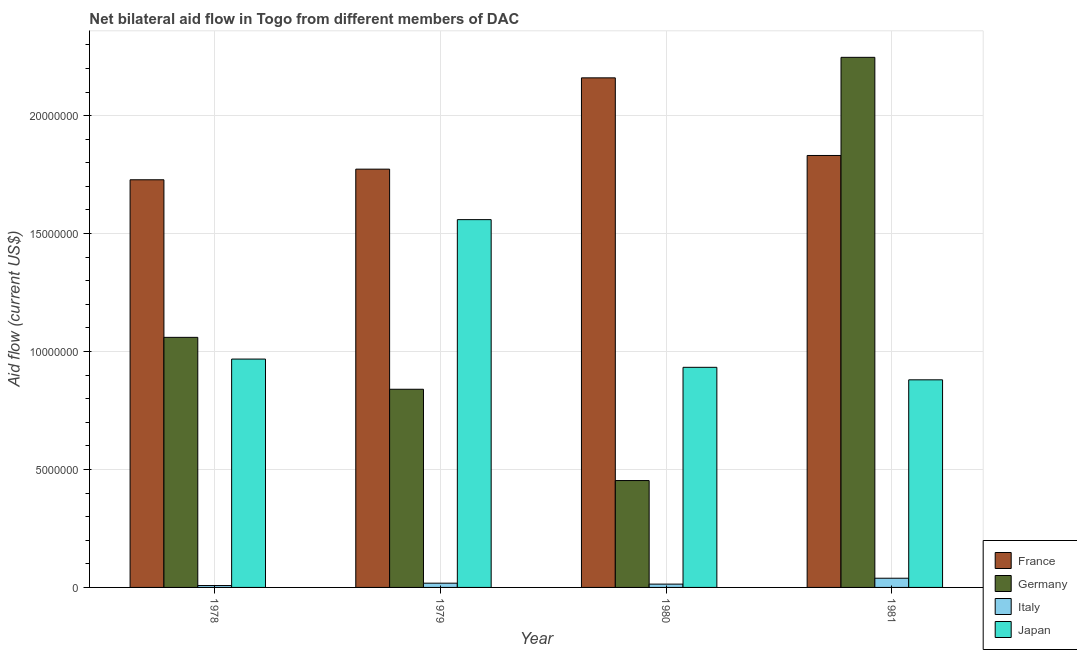How many different coloured bars are there?
Offer a terse response. 4. Are the number of bars per tick equal to the number of legend labels?
Make the answer very short. Yes. How many bars are there on the 3rd tick from the right?
Offer a terse response. 4. What is the label of the 3rd group of bars from the left?
Provide a short and direct response. 1980. What is the amount of aid given by italy in 1980?
Provide a short and direct response. 1.40e+05. Across all years, what is the maximum amount of aid given by france?
Offer a terse response. 2.16e+07. Across all years, what is the minimum amount of aid given by italy?
Keep it short and to the point. 8.00e+04. In which year was the amount of aid given by italy minimum?
Offer a terse response. 1978. What is the total amount of aid given by germany in the graph?
Give a very brief answer. 4.60e+07. What is the difference between the amount of aid given by italy in 1979 and that in 1980?
Your answer should be very brief. 4.00e+04. What is the difference between the amount of aid given by italy in 1979 and the amount of aid given by germany in 1980?
Your answer should be very brief. 4.00e+04. What is the average amount of aid given by france per year?
Provide a succinct answer. 1.87e+07. In how many years, is the amount of aid given by germany greater than 20000000 US$?
Your answer should be very brief. 1. What is the ratio of the amount of aid given by japan in 1978 to that in 1979?
Make the answer very short. 0.62. Is the amount of aid given by france in 1979 less than that in 1980?
Your answer should be compact. Yes. What is the difference between the highest and the second highest amount of aid given by italy?
Make the answer very short. 2.10e+05. What is the difference between the highest and the lowest amount of aid given by italy?
Provide a succinct answer. 3.10e+05. Is the sum of the amount of aid given by germany in 1978 and 1981 greater than the maximum amount of aid given by italy across all years?
Offer a very short reply. Yes. How many bars are there?
Offer a terse response. 16. Are all the bars in the graph horizontal?
Make the answer very short. No. What is the difference between two consecutive major ticks on the Y-axis?
Your answer should be compact. 5.00e+06. Are the values on the major ticks of Y-axis written in scientific E-notation?
Provide a succinct answer. No. Does the graph contain any zero values?
Your response must be concise. No. Does the graph contain grids?
Offer a very short reply. Yes. How many legend labels are there?
Keep it short and to the point. 4. What is the title of the graph?
Your response must be concise. Net bilateral aid flow in Togo from different members of DAC. Does "Austria" appear as one of the legend labels in the graph?
Ensure brevity in your answer.  No. What is the Aid flow (current US$) in France in 1978?
Offer a terse response. 1.73e+07. What is the Aid flow (current US$) in Germany in 1978?
Make the answer very short. 1.06e+07. What is the Aid flow (current US$) of Japan in 1978?
Offer a terse response. 9.68e+06. What is the Aid flow (current US$) of France in 1979?
Keep it short and to the point. 1.77e+07. What is the Aid flow (current US$) of Germany in 1979?
Make the answer very short. 8.40e+06. What is the Aid flow (current US$) in Japan in 1979?
Your answer should be compact. 1.56e+07. What is the Aid flow (current US$) in France in 1980?
Your answer should be very brief. 2.16e+07. What is the Aid flow (current US$) in Germany in 1980?
Provide a succinct answer. 4.53e+06. What is the Aid flow (current US$) in Japan in 1980?
Make the answer very short. 9.33e+06. What is the Aid flow (current US$) in France in 1981?
Ensure brevity in your answer.  1.83e+07. What is the Aid flow (current US$) in Germany in 1981?
Your response must be concise. 2.25e+07. What is the Aid flow (current US$) of Japan in 1981?
Provide a succinct answer. 8.80e+06. Across all years, what is the maximum Aid flow (current US$) of France?
Ensure brevity in your answer.  2.16e+07. Across all years, what is the maximum Aid flow (current US$) of Germany?
Your response must be concise. 2.25e+07. Across all years, what is the maximum Aid flow (current US$) in Japan?
Your response must be concise. 1.56e+07. Across all years, what is the minimum Aid flow (current US$) of France?
Your answer should be compact. 1.73e+07. Across all years, what is the minimum Aid flow (current US$) of Germany?
Keep it short and to the point. 4.53e+06. Across all years, what is the minimum Aid flow (current US$) of Italy?
Your answer should be very brief. 8.00e+04. Across all years, what is the minimum Aid flow (current US$) of Japan?
Give a very brief answer. 8.80e+06. What is the total Aid flow (current US$) in France in the graph?
Provide a succinct answer. 7.49e+07. What is the total Aid flow (current US$) in Germany in the graph?
Your response must be concise. 4.60e+07. What is the total Aid flow (current US$) in Italy in the graph?
Ensure brevity in your answer.  7.90e+05. What is the total Aid flow (current US$) of Japan in the graph?
Provide a short and direct response. 4.34e+07. What is the difference between the Aid flow (current US$) in France in 1978 and that in 1979?
Offer a very short reply. -4.50e+05. What is the difference between the Aid flow (current US$) of Germany in 1978 and that in 1979?
Provide a short and direct response. 2.20e+06. What is the difference between the Aid flow (current US$) in Japan in 1978 and that in 1979?
Provide a short and direct response. -5.91e+06. What is the difference between the Aid flow (current US$) in France in 1978 and that in 1980?
Make the answer very short. -4.32e+06. What is the difference between the Aid flow (current US$) in Germany in 1978 and that in 1980?
Make the answer very short. 6.07e+06. What is the difference between the Aid flow (current US$) of Italy in 1978 and that in 1980?
Offer a very short reply. -6.00e+04. What is the difference between the Aid flow (current US$) in France in 1978 and that in 1981?
Make the answer very short. -1.03e+06. What is the difference between the Aid flow (current US$) of Germany in 1978 and that in 1981?
Offer a terse response. -1.19e+07. What is the difference between the Aid flow (current US$) in Italy in 1978 and that in 1981?
Provide a short and direct response. -3.10e+05. What is the difference between the Aid flow (current US$) in Japan in 1978 and that in 1981?
Offer a very short reply. 8.80e+05. What is the difference between the Aid flow (current US$) in France in 1979 and that in 1980?
Your response must be concise. -3.87e+06. What is the difference between the Aid flow (current US$) in Germany in 1979 and that in 1980?
Keep it short and to the point. 3.87e+06. What is the difference between the Aid flow (current US$) of Japan in 1979 and that in 1980?
Offer a very short reply. 6.26e+06. What is the difference between the Aid flow (current US$) of France in 1979 and that in 1981?
Offer a terse response. -5.80e+05. What is the difference between the Aid flow (current US$) of Germany in 1979 and that in 1981?
Give a very brief answer. -1.41e+07. What is the difference between the Aid flow (current US$) of Italy in 1979 and that in 1981?
Your answer should be compact. -2.10e+05. What is the difference between the Aid flow (current US$) of Japan in 1979 and that in 1981?
Offer a very short reply. 6.79e+06. What is the difference between the Aid flow (current US$) of France in 1980 and that in 1981?
Make the answer very short. 3.29e+06. What is the difference between the Aid flow (current US$) of Germany in 1980 and that in 1981?
Provide a succinct answer. -1.79e+07. What is the difference between the Aid flow (current US$) of Italy in 1980 and that in 1981?
Give a very brief answer. -2.50e+05. What is the difference between the Aid flow (current US$) in Japan in 1980 and that in 1981?
Offer a very short reply. 5.30e+05. What is the difference between the Aid flow (current US$) of France in 1978 and the Aid flow (current US$) of Germany in 1979?
Ensure brevity in your answer.  8.88e+06. What is the difference between the Aid flow (current US$) of France in 1978 and the Aid flow (current US$) of Italy in 1979?
Keep it short and to the point. 1.71e+07. What is the difference between the Aid flow (current US$) in France in 1978 and the Aid flow (current US$) in Japan in 1979?
Your answer should be very brief. 1.69e+06. What is the difference between the Aid flow (current US$) of Germany in 1978 and the Aid flow (current US$) of Italy in 1979?
Offer a very short reply. 1.04e+07. What is the difference between the Aid flow (current US$) of Germany in 1978 and the Aid flow (current US$) of Japan in 1979?
Your answer should be compact. -4.99e+06. What is the difference between the Aid flow (current US$) in Italy in 1978 and the Aid flow (current US$) in Japan in 1979?
Keep it short and to the point. -1.55e+07. What is the difference between the Aid flow (current US$) of France in 1978 and the Aid flow (current US$) of Germany in 1980?
Your response must be concise. 1.28e+07. What is the difference between the Aid flow (current US$) of France in 1978 and the Aid flow (current US$) of Italy in 1980?
Offer a terse response. 1.71e+07. What is the difference between the Aid flow (current US$) of France in 1978 and the Aid flow (current US$) of Japan in 1980?
Offer a very short reply. 7.95e+06. What is the difference between the Aid flow (current US$) in Germany in 1978 and the Aid flow (current US$) in Italy in 1980?
Your answer should be compact. 1.05e+07. What is the difference between the Aid flow (current US$) of Germany in 1978 and the Aid flow (current US$) of Japan in 1980?
Give a very brief answer. 1.27e+06. What is the difference between the Aid flow (current US$) in Italy in 1978 and the Aid flow (current US$) in Japan in 1980?
Offer a very short reply. -9.25e+06. What is the difference between the Aid flow (current US$) of France in 1978 and the Aid flow (current US$) of Germany in 1981?
Offer a terse response. -5.19e+06. What is the difference between the Aid flow (current US$) of France in 1978 and the Aid flow (current US$) of Italy in 1981?
Offer a terse response. 1.69e+07. What is the difference between the Aid flow (current US$) of France in 1978 and the Aid flow (current US$) of Japan in 1981?
Provide a short and direct response. 8.48e+06. What is the difference between the Aid flow (current US$) in Germany in 1978 and the Aid flow (current US$) in Italy in 1981?
Provide a short and direct response. 1.02e+07. What is the difference between the Aid flow (current US$) of Germany in 1978 and the Aid flow (current US$) of Japan in 1981?
Your response must be concise. 1.80e+06. What is the difference between the Aid flow (current US$) in Italy in 1978 and the Aid flow (current US$) in Japan in 1981?
Your response must be concise. -8.72e+06. What is the difference between the Aid flow (current US$) in France in 1979 and the Aid flow (current US$) in Germany in 1980?
Your answer should be very brief. 1.32e+07. What is the difference between the Aid flow (current US$) in France in 1979 and the Aid flow (current US$) in Italy in 1980?
Provide a succinct answer. 1.76e+07. What is the difference between the Aid flow (current US$) in France in 1979 and the Aid flow (current US$) in Japan in 1980?
Offer a very short reply. 8.40e+06. What is the difference between the Aid flow (current US$) in Germany in 1979 and the Aid flow (current US$) in Italy in 1980?
Keep it short and to the point. 8.26e+06. What is the difference between the Aid flow (current US$) in Germany in 1979 and the Aid flow (current US$) in Japan in 1980?
Provide a succinct answer. -9.30e+05. What is the difference between the Aid flow (current US$) of Italy in 1979 and the Aid flow (current US$) of Japan in 1980?
Give a very brief answer. -9.15e+06. What is the difference between the Aid flow (current US$) of France in 1979 and the Aid flow (current US$) of Germany in 1981?
Ensure brevity in your answer.  -4.74e+06. What is the difference between the Aid flow (current US$) in France in 1979 and the Aid flow (current US$) in Italy in 1981?
Ensure brevity in your answer.  1.73e+07. What is the difference between the Aid flow (current US$) of France in 1979 and the Aid flow (current US$) of Japan in 1981?
Your answer should be compact. 8.93e+06. What is the difference between the Aid flow (current US$) of Germany in 1979 and the Aid flow (current US$) of Italy in 1981?
Your answer should be very brief. 8.01e+06. What is the difference between the Aid flow (current US$) in Germany in 1979 and the Aid flow (current US$) in Japan in 1981?
Ensure brevity in your answer.  -4.00e+05. What is the difference between the Aid flow (current US$) of Italy in 1979 and the Aid flow (current US$) of Japan in 1981?
Give a very brief answer. -8.62e+06. What is the difference between the Aid flow (current US$) in France in 1980 and the Aid flow (current US$) in Germany in 1981?
Provide a short and direct response. -8.70e+05. What is the difference between the Aid flow (current US$) in France in 1980 and the Aid flow (current US$) in Italy in 1981?
Ensure brevity in your answer.  2.12e+07. What is the difference between the Aid flow (current US$) of France in 1980 and the Aid flow (current US$) of Japan in 1981?
Offer a very short reply. 1.28e+07. What is the difference between the Aid flow (current US$) in Germany in 1980 and the Aid flow (current US$) in Italy in 1981?
Your answer should be compact. 4.14e+06. What is the difference between the Aid flow (current US$) of Germany in 1980 and the Aid flow (current US$) of Japan in 1981?
Provide a short and direct response. -4.27e+06. What is the difference between the Aid flow (current US$) of Italy in 1980 and the Aid flow (current US$) of Japan in 1981?
Your answer should be very brief. -8.66e+06. What is the average Aid flow (current US$) of France per year?
Your answer should be very brief. 1.87e+07. What is the average Aid flow (current US$) of Germany per year?
Your response must be concise. 1.15e+07. What is the average Aid flow (current US$) of Italy per year?
Offer a terse response. 1.98e+05. What is the average Aid flow (current US$) in Japan per year?
Provide a short and direct response. 1.08e+07. In the year 1978, what is the difference between the Aid flow (current US$) in France and Aid flow (current US$) in Germany?
Your answer should be very brief. 6.68e+06. In the year 1978, what is the difference between the Aid flow (current US$) of France and Aid flow (current US$) of Italy?
Ensure brevity in your answer.  1.72e+07. In the year 1978, what is the difference between the Aid flow (current US$) in France and Aid flow (current US$) in Japan?
Your response must be concise. 7.60e+06. In the year 1978, what is the difference between the Aid flow (current US$) in Germany and Aid flow (current US$) in Italy?
Your response must be concise. 1.05e+07. In the year 1978, what is the difference between the Aid flow (current US$) in Germany and Aid flow (current US$) in Japan?
Keep it short and to the point. 9.20e+05. In the year 1978, what is the difference between the Aid flow (current US$) in Italy and Aid flow (current US$) in Japan?
Your answer should be very brief. -9.60e+06. In the year 1979, what is the difference between the Aid flow (current US$) in France and Aid flow (current US$) in Germany?
Keep it short and to the point. 9.33e+06. In the year 1979, what is the difference between the Aid flow (current US$) in France and Aid flow (current US$) in Italy?
Provide a short and direct response. 1.76e+07. In the year 1979, what is the difference between the Aid flow (current US$) in France and Aid flow (current US$) in Japan?
Your response must be concise. 2.14e+06. In the year 1979, what is the difference between the Aid flow (current US$) in Germany and Aid flow (current US$) in Italy?
Offer a very short reply. 8.22e+06. In the year 1979, what is the difference between the Aid flow (current US$) in Germany and Aid flow (current US$) in Japan?
Ensure brevity in your answer.  -7.19e+06. In the year 1979, what is the difference between the Aid flow (current US$) of Italy and Aid flow (current US$) of Japan?
Make the answer very short. -1.54e+07. In the year 1980, what is the difference between the Aid flow (current US$) of France and Aid flow (current US$) of Germany?
Your answer should be compact. 1.71e+07. In the year 1980, what is the difference between the Aid flow (current US$) of France and Aid flow (current US$) of Italy?
Provide a short and direct response. 2.15e+07. In the year 1980, what is the difference between the Aid flow (current US$) of France and Aid flow (current US$) of Japan?
Your answer should be very brief. 1.23e+07. In the year 1980, what is the difference between the Aid flow (current US$) of Germany and Aid flow (current US$) of Italy?
Provide a succinct answer. 4.39e+06. In the year 1980, what is the difference between the Aid flow (current US$) of Germany and Aid flow (current US$) of Japan?
Your answer should be very brief. -4.80e+06. In the year 1980, what is the difference between the Aid flow (current US$) in Italy and Aid flow (current US$) in Japan?
Offer a terse response. -9.19e+06. In the year 1981, what is the difference between the Aid flow (current US$) in France and Aid flow (current US$) in Germany?
Your answer should be compact. -4.16e+06. In the year 1981, what is the difference between the Aid flow (current US$) in France and Aid flow (current US$) in Italy?
Offer a terse response. 1.79e+07. In the year 1981, what is the difference between the Aid flow (current US$) of France and Aid flow (current US$) of Japan?
Offer a terse response. 9.51e+06. In the year 1981, what is the difference between the Aid flow (current US$) of Germany and Aid flow (current US$) of Italy?
Ensure brevity in your answer.  2.21e+07. In the year 1981, what is the difference between the Aid flow (current US$) of Germany and Aid flow (current US$) of Japan?
Offer a terse response. 1.37e+07. In the year 1981, what is the difference between the Aid flow (current US$) of Italy and Aid flow (current US$) of Japan?
Offer a very short reply. -8.41e+06. What is the ratio of the Aid flow (current US$) in France in 1978 to that in 1979?
Your answer should be compact. 0.97. What is the ratio of the Aid flow (current US$) of Germany in 1978 to that in 1979?
Your response must be concise. 1.26. What is the ratio of the Aid flow (current US$) of Italy in 1978 to that in 1979?
Your response must be concise. 0.44. What is the ratio of the Aid flow (current US$) of Japan in 1978 to that in 1979?
Offer a very short reply. 0.62. What is the ratio of the Aid flow (current US$) in Germany in 1978 to that in 1980?
Ensure brevity in your answer.  2.34. What is the ratio of the Aid flow (current US$) of Italy in 1978 to that in 1980?
Give a very brief answer. 0.57. What is the ratio of the Aid flow (current US$) in Japan in 1978 to that in 1980?
Provide a succinct answer. 1.04. What is the ratio of the Aid flow (current US$) in France in 1978 to that in 1981?
Your response must be concise. 0.94. What is the ratio of the Aid flow (current US$) of Germany in 1978 to that in 1981?
Your answer should be very brief. 0.47. What is the ratio of the Aid flow (current US$) of Italy in 1978 to that in 1981?
Offer a terse response. 0.21. What is the ratio of the Aid flow (current US$) of Japan in 1978 to that in 1981?
Ensure brevity in your answer.  1.1. What is the ratio of the Aid flow (current US$) in France in 1979 to that in 1980?
Your response must be concise. 0.82. What is the ratio of the Aid flow (current US$) of Germany in 1979 to that in 1980?
Provide a short and direct response. 1.85. What is the ratio of the Aid flow (current US$) of Italy in 1979 to that in 1980?
Offer a terse response. 1.29. What is the ratio of the Aid flow (current US$) in Japan in 1979 to that in 1980?
Offer a terse response. 1.67. What is the ratio of the Aid flow (current US$) of France in 1979 to that in 1981?
Your answer should be very brief. 0.97. What is the ratio of the Aid flow (current US$) in Germany in 1979 to that in 1981?
Provide a succinct answer. 0.37. What is the ratio of the Aid flow (current US$) of Italy in 1979 to that in 1981?
Provide a short and direct response. 0.46. What is the ratio of the Aid flow (current US$) of Japan in 1979 to that in 1981?
Ensure brevity in your answer.  1.77. What is the ratio of the Aid flow (current US$) of France in 1980 to that in 1981?
Keep it short and to the point. 1.18. What is the ratio of the Aid flow (current US$) of Germany in 1980 to that in 1981?
Your answer should be very brief. 0.2. What is the ratio of the Aid flow (current US$) of Italy in 1980 to that in 1981?
Offer a very short reply. 0.36. What is the ratio of the Aid flow (current US$) in Japan in 1980 to that in 1981?
Your answer should be compact. 1.06. What is the difference between the highest and the second highest Aid flow (current US$) of France?
Give a very brief answer. 3.29e+06. What is the difference between the highest and the second highest Aid flow (current US$) of Germany?
Your answer should be very brief. 1.19e+07. What is the difference between the highest and the second highest Aid flow (current US$) of Italy?
Provide a succinct answer. 2.10e+05. What is the difference between the highest and the second highest Aid flow (current US$) of Japan?
Your answer should be very brief. 5.91e+06. What is the difference between the highest and the lowest Aid flow (current US$) in France?
Give a very brief answer. 4.32e+06. What is the difference between the highest and the lowest Aid flow (current US$) in Germany?
Keep it short and to the point. 1.79e+07. What is the difference between the highest and the lowest Aid flow (current US$) of Japan?
Keep it short and to the point. 6.79e+06. 